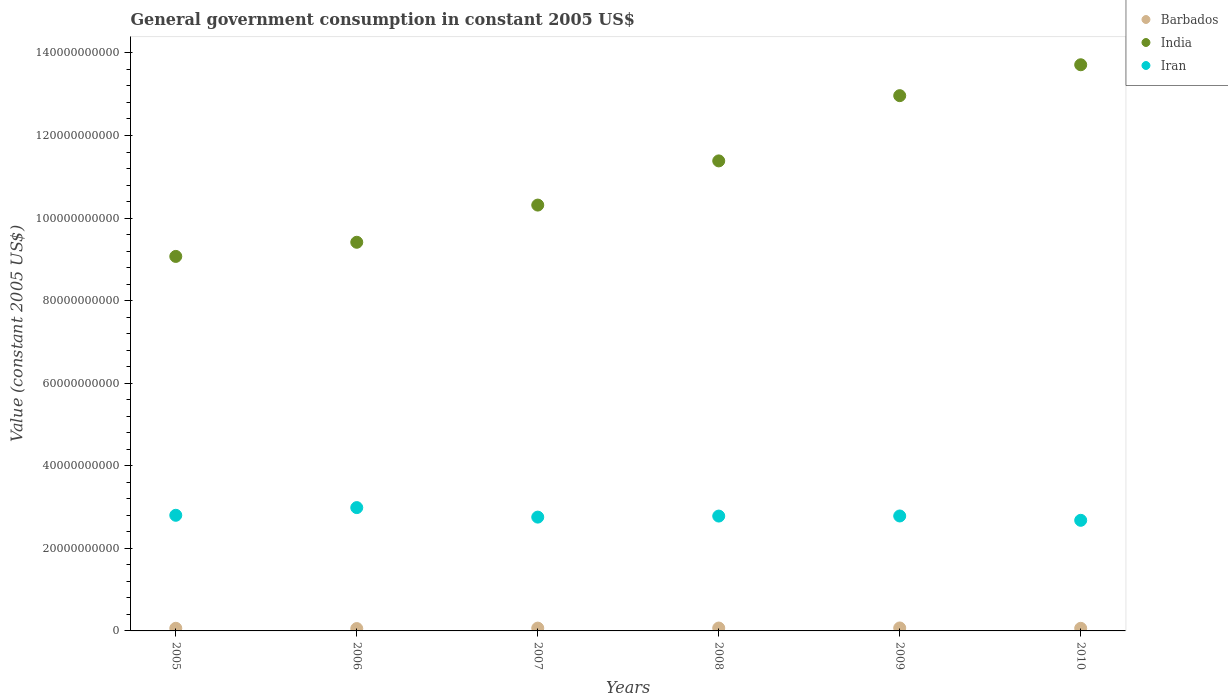How many different coloured dotlines are there?
Ensure brevity in your answer.  3. Is the number of dotlines equal to the number of legend labels?
Provide a succinct answer. Yes. What is the government conusmption in Iran in 2010?
Offer a very short reply. 2.68e+1. Across all years, what is the maximum government conusmption in Barbados?
Ensure brevity in your answer.  7.16e+08. Across all years, what is the minimum government conusmption in Iran?
Your response must be concise. 2.68e+1. In which year was the government conusmption in Iran maximum?
Your answer should be very brief. 2006. What is the total government conusmption in Barbados in the graph?
Your answer should be very brief. 3.93e+09. What is the difference between the government conusmption in India in 2007 and that in 2009?
Your answer should be very brief. -2.65e+1. What is the difference between the government conusmption in Iran in 2009 and the government conusmption in Barbados in 2007?
Provide a succinct answer. 2.72e+1. What is the average government conusmption in Barbados per year?
Your response must be concise. 6.55e+08. In the year 2010, what is the difference between the government conusmption in Iran and government conusmption in India?
Offer a very short reply. -1.10e+11. In how many years, is the government conusmption in India greater than 8000000000 US$?
Your answer should be compact. 6. What is the ratio of the government conusmption in Barbados in 2005 to that in 2009?
Your response must be concise. 0.89. What is the difference between the highest and the second highest government conusmption in Barbados?
Ensure brevity in your answer.  1.70e+07. What is the difference between the highest and the lowest government conusmption in Barbados?
Keep it short and to the point. 1.46e+08. Is the government conusmption in Barbados strictly less than the government conusmption in India over the years?
Provide a short and direct response. Yes. How many dotlines are there?
Your answer should be compact. 3. How many years are there in the graph?
Your response must be concise. 6. What is the difference between two consecutive major ticks on the Y-axis?
Your response must be concise. 2.00e+1. Are the values on the major ticks of Y-axis written in scientific E-notation?
Your response must be concise. No. Does the graph contain any zero values?
Your answer should be very brief. No. Does the graph contain grids?
Your answer should be very brief. No. What is the title of the graph?
Make the answer very short. General government consumption in constant 2005 US$. Does "Argentina" appear as one of the legend labels in the graph?
Keep it short and to the point. No. What is the label or title of the X-axis?
Make the answer very short. Years. What is the label or title of the Y-axis?
Offer a terse response. Value (constant 2005 US$). What is the Value (constant 2005 US$) in Barbados in 2005?
Your answer should be compact. 6.38e+08. What is the Value (constant 2005 US$) of India in 2005?
Make the answer very short. 9.07e+1. What is the Value (constant 2005 US$) of Iran in 2005?
Offer a very short reply. 2.80e+1. What is the Value (constant 2005 US$) in Barbados in 2006?
Your answer should be compact. 5.70e+08. What is the Value (constant 2005 US$) of India in 2006?
Provide a short and direct response. 9.41e+1. What is the Value (constant 2005 US$) of Iran in 2006?
Keep it short and to the point. 2.99e+1. What is the Value (constant 2005 US$) of Barbados in 2007?
Offer a very short reply. 6.79e+08. What is the Value (constant 2005 US$) of India in 2007?
Your response must be concise. 1.03e+11. What is the Value (constant 2005 US$) of Iran in 2007?
Provide a succinct answer. 2.76e+1. What is the Value (constant 2005 US$) in Barbados in 2008?
Offer a terse response. 6.99e+08. What is the Value (constant 2005 US$) in India in 2008?
Provide a short and direct response. 1.14e+11. What is the Value (constant 2005 US$) in Iran in 2008?
Offer a terse response. 2.78e+1. What is the Value (constant 2005 US$) in Barbados in 2009?
Make the answer very short. 7.16e+08. What is the Value (constant 2005 US$) in India in 2009?
Provide a succinct answer. 1.30e+11. What is the Value (constant 2005 US$) of Iran in 2009?
Offer a very short reply. 2.78e+1. What is the Value (constant 2005 US$) in Barbados in 2010?
Offer a very short reply. 6.31e+08. What is the Value (constant 2005 US$) of India in 2010?
Your answer should be compact. 1.37e+11. What is the Value (constant 2005 US$) of Iran in 2010?
Give a very brief answer. 2.68e+1. Across all years, what is the maximum Value (constant 2005 US$) in Barbados?
Give a very brief answer. 7.16e+08. Across all years, what is the maximum Value (constant 2005 US$) in India?
Give a very brief answer. 1.37e+11. Across all years, what is the maximum Value (constant 2005 US$) of Iran?
Provide a short and direct response. 2.99e+1. Across all years, what is the minimum Value (constant 2005 US$) of Barbados?
Offer a terse response. 5.70e+08. Across all years, what is the minimum Value (constant 2005 US$) in India?
Keep it short and to the point. 9.07e+1. Across all years, what is the minimum Value (constant 2005 US$) in Iran?
Offer a terse response. 2.68e+1. What is the total Value (constant 2005 US$) of Barbados in the graph?
Offer a terse response. 3.93e+09. What is the total Value (constant 2005 US$) in India in the graph?
Offer a terse response. 6.69e+11. What is the total Value (constant 2005 US$) of Iran in the graph?
Provide a short and direct response. 1.68e+11. What is the difference between the Value (constant 2005 US$) in Barbados in 2005 and that in 2006?
Your answer should be compact. 6.82e+07. What is the difference between the Value (constant 2005 US$) in India in 2005 and that in 2006?
Ensure brevity in your answer.  -3.42e+09. What is the difference between the Value (constant 2005 US$) in Iran in 2005 and that in 2006?
Ensure brevity in your answer.  -1.86e+09. What is the difference between the Value (constant 2005 US$) in Barbados in 2005 and that in 2007?
Provide a succinct answer. -4.14e+07. What is the difference between the Value (constant 2005 US$) of India in 2005 and that in 2007?
Keep it short and to the point. -1.24e+1. What is the difference between the Value (constant 2005 US$) of Iran in 2005 and that in 2007?
Offer a terse response. 4.43e+08. What is the difference between the Value (constant 2005 US$) of Barbados in 2005 and that in 2008?
Offer a very short reply. -6.09e+07. What is the difference between the Value (constant 2005 US$) in India in 2005 and that in 2008?
Give a very brief answer. -2.31e+1. What is the difference between the Value (constant 2005 US$) of Iran in 2005 and that in 2008?
Ensure brevity in your answer.  1.92e+08. What is the difference between the Value (constant 2005 US$) of Barbados in 2005 and that in 2009?
Make the answer very short. -7.79e+07. What is the difference between the Value (constant 2005 US$) of India in 2005 and that in 2009?
Ensure brevity in your answer.  -3.89e+1. What is the difference between the Value (constant 2005 US$) in Iran in 2005 and that in 2009?
Your response must be concise. 1.68e+08. What is the difference between the Value (constant 2005 US$) of Barbados in 2005 and that in 2010?
Offer a terse response. 7.31e+06. What is the difference between the Value (constant 2005 US$) of India in 2005 and that in 2010?
Your response must be concise. -4.64e+1. What is the difference between the Value (constant 2005 US$) in Iran in 2005 and that in 2010?
Provide a succinct answer. 1.22e+09. What is the difference between the Value (constant 2005 US$) of Barbados in 2006 and that in 2007?
Offer a terse response. -1.10e+08. What is the difference between the Value (constant 2005 US$) of India in 2006 and that in 2007?
Ensure brevity in your answer.  -9.01e+09. What is the difference between the Value (constant 2005 US$) of Iran in 2006 and that in 2007?
Give a very brief answer. 2.30e+09. What is the difference between the Value (constant 2005 US$) of Barbados in 2006 and that in 2008?
Provide a succinct answer. -1.29e+08. What is the difference between the Value (constant 2005 US$) in India in 2006 and that in 2008?
Your answer should be compact. -1.97e+1. What is the difference between the Value (constant 2005 US$) in Iran in 2006 and that in 2008?
Your answer should be compact. 2.05e+09. What is the difference between the Value (constant 2005 US$) of Barbados in 2006 and that in 2009?
Offer a terse response. -1.46e+08. What is the difference between the Value (constant 2005 US$) of India in 2006 and that in 2009?
Ensure brevity in your answer.  -3.55e+1. What is the difference between the Value (constant 2005 US$) of Iran in 2006 and that in 2009?
Provide a succinct answer. 2.03e+09. What is the difference between the Value (constant 2005 US$) of Barbados in 2006 and that in 2010?
Provide a short and direct response. -6.09e+07. What is the difference between the Value (constant 2005 US$) in India in 2006 and that in 2010?
Ensure brevity in your answer.  -4.30e+1. What is the difference between the Value (constant 2005 US$) of Iran in 2006 and that in 2010?
Make the answer very short. 3.08e+09. What is the difference between the Value (constant 2005 US$) of Barbados in 2007 and that in 2008?
Provide a succinct answer. -1.95e+07. What is the difference between the Value (constant 2005 US$) in India in 2007 and that in 2008?
Ensure brevity in your answer.  -1.07e+1. What is the difference between the Value (constant 2005 US$) of Iran in 2007 and that in 2008?
Keep it short and to the point. -2.51e+08. What is the difference between the Value (constant 2005 US$) of Barbados in 2007 and that in 2009?
Your response must be concise. -3.65e+07. What is the difference between the Value (constant 2005 US$) of India in 2007 and that in 2009?
Keep it short and to the point. -2.65e+1. What is the difference between the Value (constant 2005 US$) in Iran in 2007 and that in 2009?
Your answer should be very brief. -2.75e+08. What is the difference between the Value (constant 2005 US$) of Barbados in 2007 and that in 2010?
Offer a very short reply. 4.87e+07. What is the difference between the Value (constant 2005 US$) in India in 2007 and that in 2010?
Provide a short and direct response. -3.40e+1. What is the difference between the Value (constant 2005 US$) in Iran in 2007 and that in 2010?
Provide a succinct answer. 7.75e+08. What is the difference between the Value (constant 2005 US$) in Barbados in 2008 and that in 2009?
Your answer should be compact. -1.70e+07. What is the difference between the Value (constant 2005 US$) of India in 2008 and that in 2009?
Offer a terse response. -1.58e+1. What is the difference between the Value (constant 2005 US$) in Iran in 2008 and that in 2009?
Your answer should be compact. -2.42e+07. What is the difference between the Value (constant 2005 US$) in Barbados in 2008 and that in 2010?
Ensure brevity in your answer.  6.82e+07. What is the difference between the Value (constant 2005 US$) in India in 2008 and that in 2010?
Your answer should be compact. -2.33e+1. What is the difference between the Value (constant 2005 US$) of Iran in 2008 and that in 2010?
Provide a succinct answer. 1.03e+09. What is the difference between the Value (constant 2005 US$) of Barbados in 2009 and that in 2010?
Ensure brevity in your answer.  8.52e+07. What is the difference between the Value (constant 2005 US$) of India in 2009 and that in 2010?
Provide a short and direct response. -7.48e+09. What is the difference between the Value (constant 2005 US$) of Iran in 2009 and that in 2010?
Keep it short and to the point. 1.05e+09. What is the difference between the Value (constant 2005 US$) in Barbados in 2005 and the Value (constant 2005 US$) in India in 2006?
Provide a short and direct response. -9.35e+1. What is the difference between the Value (constant 2005 US$) in Barbados in 2005 and the Value (constant 2005 US$) in Iran in 2006?
Offer a terse response. -2.92e+1. What is the difference between the Value (constant 2005 US$) in India in 2005 and the Value (constant 2005 US$) in Iran in 2006?
Give a very brief answer. 6.08e+1. What is the difference between the Value (constant 2005 US$) in Barbados in 2005 and the Value (constant 2005 US$) in India in 2007?
Your answer should be compact. -1.03e+11. What is the difference between the Value (constant 2005 US$) of Barbados in 2005 and the Value (constant 2005 US$) of Iran in 2007?
Ensure brevity in your answer.  -2.69e+1. What is the difference between the Value (constant 2005 US$) of India in 2005 and the Value (constant 2005 US$) of Iran in 2007?
Give a very brief answer. 6.31e+1. What is the difference between the Value (constant 2005 US$) in Barbados in 2005 and the Value (constant 2005 US$) in India in 2008?
Provide a succinct answer. -1.13e+11. What is the difference between the Value (constant 2005 US$) in Barbados in 2005 and the Value (constant 2005 US$) in Iran in 2008?
Keep it short and to the point. -2.72e+1. What is the difference between the Value (constant 2005 US$) in India in 2005 and the Value (constant 2005 US$) in Iran in 2008?
Your answer should be very brief. 6.29e+1. What is the difference between the Value (constant 2005 US$) in Barbados in 2005 and the Value (constant 2005 US$) in India in 2009?
Your answer should be very brief. -1.29e+11. What is the difference between the Value (constant 2005 US$) of Barbados in 2005 and the Value (constant 2005 US$) of Iran in 2009?
Offer a terse response. -2.72e+1. What is the difference between the Value (constant 2005 US$) in India in 2005 and the Value (constant 2005 US$) in Iran in 2009?
Provide a succinct answer. 6.29e+1. What is the difference between the Value (constant 2005 US$) of Barbados in 2005 and the Value (constant 2005 US$) of India in 2010?
Give a very brief answer. -1.36e+11. What is the difference between the Value (constant 2005 US$) in Barbados in 2005 and the Value (constant 2005 US$) in Iran in 2010?
Your answer should be compact. -2.62e+1. What is the difference between the Value (constant 2005 US$) of India in 2005 and the Value (constant 2005 US$) of Iran in 2010?
Provide a succinct answer. 6.39e+1. What is the difference between the Value (constant 2005 US$) of Barbados in 2006 and the Value (constant 2005 US$) of India in 2007?
Give a very brief answer. -1.03e+11. What is the difference between the Value (constant 2005 US$) in Barbados in 2006 and the Value (constant 2005 US$) in Iran in 2007?
Provide a succinct answer. -2.70e+1. What is the difference between the Value (constant 2005 US$) of India in 2006 and the Value (constant 2005 US$) of Iran in 2007?
Keep it short and to the point. 6.66e+1. What is the difference between the Value (constant 2005 US$) in Barbados in 2006 and the Value (constant 2005 US$) in India in 2008?
Keep it short and to the point. -1.13e+11. What is the difference between the Value (constant 2005 US$) in Barbados in 2006 and the Value (constant 2005 US$) in Iran in 2008?
Your answer should be compact. -2.72e+1. What is the difference between the Value (constant 2005 US$) of India in 2006 and the Value (constant 2005 US$) of Iran in 2008?
Your response must be concise. 6.63e+1. What is the difference between the Value (constant 2005 US$) in Barbados in 2006 and the Value (constant 2005 US$) in India in 2009?
Ensure brevity in your answer.  -1.29e+11. What is the difference between the Value (constant 2005 US$) in Barbados in 2006 and the Value (constant 2005 US$) in Iran in 2009?
Offer a terse response. -2.73e+1. What is the difference between the Value (constant 2005 US$) of India in 2006 and the Value (constant 2005 US$) of Iran in 2009?
Give a very brief answer. 6.63e+1. What is the difference between the Value (constant 2005 US$) in Barbados in 2006 and the Value (constant 2005 US$) in India in 2010?
Your response must be concise. -1.37e+11. What is the difference between the Value (constant 2005 US$) of Barbados in 2006 and the Value (constant 2005 US$) of Iran in 2010?
Give a very brief answer. -2.62e+1. What is the difference between the Value (constant 2005 US$) in India in 2006 and the Value (constant 2005 US$) in Iran in 2010?
Offer a very short reply. 6.73e+1. What is the difference between the Value (constant 2005 US$) in Barbados in 2007 and the Value (constant 2005 US$) in India in 2008?
Ensure brevity in your answer.  -1.13e+11. What is the difference between the Value (constant 2005 US$) in Barbados in 2007 and the Value (constant 2005 US$) in Iran in 2008?
Offer a very short reply. -2.71e+1. What is the difference between the Value (constant 2005 US$) of India in 2007 and the Value (constant 2005 US$) of Iran in 2008?
Provide a short and direct response. 7.53e+1. What is the difference between the Value (constant 2005 US$) in Barbados in 2007 and the Value (constant 2005 US$) in India in 2009?
Offer a very short reply. -1.29e+11. What is the difference between the Value (constant 2005 US$) in Barbados in 2007 and the Value (constant 2005 US$) in Iran in 2009?
Provide a succinct answer. -2.72e+1. What is the difference between the Value (constant 2005 US$) in India in 2007 and the Value (constant 2005 US$) in Iran in 2009?
Make the answer very short. 7.53e+1. What is the difference between the Value (constant 2005 US$) in Barbados in 2007 and the Value (constant 2005 US$) in India in 2010?
Provide a succinct answer. -1.36e+11. What is the difference between the Value (constant 2005 US$) in Barbados in 2007 and the Value (constant 2005 US$) in Iran in 2010?
Give a very brief answer. -2.61e+1. What is the difference between the Value (constant 2005 US$) of India in 2007 and the Value (constant 2005 US$) of Iran in 2010?
Offer a terse response. 7.64e+1. What is the difference between the Value (constant 2005 US$) of Barbados in 2008 and the Value (constant 2005 US$) of India in 2009?
Provide a succinct answer. -1.29e+11. What is the difference between the Value (constant 2005 US$) in Barbados in 2008 and the Value (constant 2005 US$) in Iran in 2009?
Make the answer very short. -2.71e+1. What is the difference between the Value (constant 2005 US$) of India in 2008 and the Value (constant 2005 US$) of Iran in 2009?
Provide a short and direct response. 8.60e+1. What is the difference between the Value (constant 2005 US$) of Barbados in 2008 and the Value (constant 2005 US$) of India in 2010?
Offer a terse response. -1.36e+11. What is the difference between the Value (constant 2005 US$) of Barbados in 2008 and the Value (constant 2005 US$) of Iran in 2010?
Offer a very short reply. -2.61e+1. What is the difference between the Value (constant 2005 US$) in India in 2008 and the Value (constant 2005 US$) in Iran in 2010?
Ensure brevity in your answer.  8.71e+1. What is the difference between the Value (constant 2005 US$) of Barbados in 2009 and the Value (constant 2005 US$) of India in 2010?
Provide a short and direct response. -1.36e+11. What is the difference between the Value (constant 2005 US$) of Barbados in 2009 and the Value (constant 2005 US$) of Iran in 2010?
Your answer should be very brief. -2.61e+1. What is the difference between the Value (constant 2005 US$) of India in 2009 and the Value (constant 2005 US$) of Iran in 2010?
Your answer should be very brief. 1.03e+11. What is the average Value (constant 2005 US$) of Barbados per year?
Keep it short and to the point. 6.55e+08. What is the average Value (constant 2005 US$) of India per year?
Your answer should be very brief. 1.11e+11. What is the average Value (constant 2005 US$) in Iran per year?
Give a very brief answer. 2.80e+1. In the year 2005, what is the difference between the Value (constant 2005 US$) of Barbados and Value (constant 2005 US$) of India?
Ensure brevity in your answer.  -9.01e+1. In the year 2005, what is the difference between the Value (constant 2005 US$) in Barbados and Value (constant 2005 US$) in Iran?
Provide a short and direct response. -2.74e+1. In the year 2005, what is the difference between the Value (constant 2005 US$) of India and Value (constant 2005 US$) of Iran?
Keep it short and to the point. 6.27e+1. In the year 2006, what is the difference between the Value (constant 2005 US$) in Barbados and Value (constant 2005 US$) in India?
Offer a terse response. -9.36e+1. In the year 2006, what is the difference between the Value (constant 2005 US$) in Barbados and Value (constant 2005 US$) in Iran?
Your answer should be very brief. -2.93e+1. In the year 2006, what is the difference between the Value (constant 2005 US$) of India and Value (constant 2005 US$) of Iran?
Offer a very short reply. 6.43e+1. In the year 2007, what is the difference between the Value (constant 2005 US$) of Barbados and Value (constant 2005 US$) of India?
Keep it short and to the point. -1.02e+11. In the year 2007, what is the difference between the Value (constant 2005 US$) in Barbados and Value (constant 2005 US$) in Iran?
Your answer should be compact. -2.69e+1. In the year 2007, what is the difference between the Value (constant 2005 US$) of India and Value (constant 2005 US$) of Iran?
Offer a very short reply. 7.56e+1. In the year 2008, what is the difference between the Value (constant 2005 US$) of Barbados and Value (constant 2005 US$) of India?
Your response must be concise. -1.13e+11. In the year 2008, what is the difference between the Value (constant 2005 US$) in Barbados and Value (constant 2005 US$) in Iran?
Your answer should be compact. -2.71e+1. In the year 2008, what is the difference between the Value (constant 2005 US$) of India and Value (constant 2005 US$) of Iran?
Your answer should be compact. 8.60e+1. In the year 2009, what is the difference between the Value (constant 2005 US$) of Barbados and Value (constant 2005 US$) of India?
Give a very brief answer. -1.29e+11. In the year 2009, what is the difference between the Value (constant 2005 US$) in Barbados and Value (constant 2005 US$) in Iran?
Offer a very short reply. -2.71e+1. In the year 2009, what is the difference between the Value (constant 2005 US$) in India and Value (constant 2005 US$) in Iran?
Provide a short and direct response. 1.02e+11. In the year 2010, what is the difference between the Value (constant 2005 US$) in Barbados and Value (constant 2005 US$) in India?
Your response must be concise. -1.37e+11. In the year 2010, what is the difference between the Value (constant 2005 US$) of Barbados and Value (constant 2005 US$) of Iran?
Your answer should be very brief. -2.62e+1. In the year 2010, what is the difference between the Value (constant 2005 US$) in India and Value (constant 2005 US$) in Iran?
Make the answer very short. 1.10e+11. What is the ratio of the Value (constant 2005 US$) of Barbados in 2005 to that in 2006?
Provide a succinct answer. 1.12. What is the ratio of the Value (constant 2005 US$) of India in 2005 to that in 2006?
Offer a terse response. 0.96. What is the ratio of the Value (constant 2005 US$) of Iran in 2005 to that in 2006?
Keep it short and to the point. 0.94. What is the ratio of the Value (constant 2005 US$) of Barbados in 2005 to that in 2007?
Provide a short and direct response. 0.94. What is the ratio of the Value (constant 2005 US$) of India in 2005 to that in 2007?
Keep it short and to the point. 0.88. What is the ratio of the Value (constant 2005 US$) of Iran in 2005 to that in 2007?
Ensure brevity in your answer.  1.02. What is the ratio of the Value (constant 2005 US$) in Barbados in 2005 to that in 2008?
Your response must be concise. 0.91. What is the ratio of the Value (constant 2005 US$) of India in 2005 to that in 2008?
Keep it short and to the point. 0.8. What is the ratio of the Value (constant 2005 US$) in Barbados in 2005 to that in 2009?
Ensure brevity in your answer.  0.89. What is the ratio of the Value (constant 2005 US$) in India in 2005 to that in 2009?
Make the answer very short. 0.7. What is the ratio of the Value (constant 2005 US$) in Iran in 2005 to that in 2009?
Your answer should be very brief. 1.01. What is the ratio of the Value (constant 2005 US$) of Barbados in 2005 to that in 2010?
Give a very brief answer. 1.01. What is the ratio of the Value (constant 2005 US$) of India in 2005 to that in 2010?
Provide a short and direct response. 0.66. What is the ratio of the Value (constant 2005 US$) of Iran in 2005 to that in 2010?
Offer a very short reply. 1.05. What is the ratio of the Value (constant 2005 US$) of Barbados in 2006 to that in 2007?
Your answer should be compact. 0.84. What is the ratio of the Value (constant 2005 US$) in India in 2006 to that in 2007?
Provide a short and direct response. 0.91. What is the ratio of the Value (constant 2005 US$) in Iran in 2006 to that in 2007?
Give a very brief answer. 1.08. What is the ratio of the Value (constant 2005 US$) in Barbados in 2006 to that in 2008?
Your answer should be compact. 0.82. What is the ratio of the Value (constant 2005 US$) of India in 2006 to that in 2008?
Give a very brief answer. 0.83. What is the ratio of the Value (constant 2005 US$) of Iran in 2006 to that in 2008?
Keep it short and to the point. 1.07. What is the ratio of the Value (constant 2005 US$) in Barbados in 2006 to that in 2009?
Provide a succinct answer. 0.8. What is the ratio of the Value (constant 2005 US$) in India in 2006 to that in 2009?
Provide a short and direct response. 0.73. What is the ratio of the Value (constant 2005 US$) in Iran in 2006 to that in 2009?
Offer a terse response. 1.07. What is the ratio of the Value (constant 2005 US$) of Barbados in 2006 to that in 2010?
Your response must be concise. 0.9. What is the ratio of the Value (constant 2005 US$) in India in 2006 to that in 2010?
Your answer should be compact. 0.69. What is the ratio of the Value (constant 2005 US$) of Iran in 2006 to that in 2010?
Provide a succinct answer. 1.11. What is the ratio of the Value (constant 2005 US$) of Barbados in 2007 to that in 2008?
Offer a terse response. 0.97. What is the ratio of the Value (constant 2005 US$) of India in 2007 to that in 2008?
Your answer should be very brief. 0.91. What is the ratio of the Value (constant 2005 US$) of Iran in 2007 to that in 2008?
Make the answer very short. 0.99. What is the ratio of the Value (constant 2005 US$) of Barbados in 2007 to that in 2009?
Your response must be concise. 0.95. What is the ratio of the Value (constant 2005 US$) in India in 2007 to that in 2009?
Ensure brevity in your answer.  0.8. What is the ratio of the Value (constant 2005 US$) in Iran in 2007 to that in 2009?
Offer a terse response. 0.99. What is the ratio of the Value (constant 2005 US$) of Barbados in 2007 to that in 2010?
Provide a short and direct response. 1.08. What is the ratio of the Value (constant 2005 US$) in India in 2007 to that in 2010?
Your response must be concise. 0.75. What is the ratio of the Value (constant 2005 US$) in Iran in 2007 to that in 2010?
Give a very brief answer. 1.03. What is the ratio of the Value (constant 2005 US$) of Barbados in 2008 to that in 2009?
Provide a succinct answer. 0.98. What is the ratio of the Value (constant 2005 US$) of India in 2008 to that in 2009?
Offer a very short reply. 0.88. What is the ratio of the Value (constant 2005 US$) of Iran in 2008 to that in 2009?
Make the answer very short. 1. What is the ratio of the Value (constant 2005 US$) in Barbados in 2008 to that in 2010?
Your answer should be very brief. 1.11. What is the ratio of the Value (constant 2005 US$) of India in 2008 to that in 2010?
Keep it short and to the point. 0.83. What is the ratio of the Value (constant 2005 US$) in Iran in 2008 to that in 2010?
Your response must be concise. 1.04. What is the ratio of the Value (constant 2005 US$) of Barbados in 2009 to that in 2010?
Your response must be concise. 1.14. What is the ratio of the Value (constant 2005 US$) of India in 2009 to that in 2010?
Your answer should be very brief. 0.95. What is the ratio of the Value (constant 2005 US$) of Iran in 2009 to that in 2010?
Your answer should be compact. 1.04. What is the difference between the highest and the second highest Value (constant 2005 US$) in Barbados?
Give a very brief answer. 1.70e+07. What is the difference between the highest and the second highest Value (constant 2005 US$) of India?
Your answer should be compact. 7.48e+09. What is the difference between the highest and the second highest Value (constant 2005 US$) of Iran?
Keep it short and to the point. 1.86e+09. What is the difference between the highest and the lowest Value (constant 2005 US$) of Barbados?
Your response must be concise. 1.46e+08. What is the difference between the highest and the lowest Value (constant 2005 US$) of India?
Offer a very short reply. 4.64e+1. What is the difference between the highest and the lowest Value (constant 2005 US$) in Iran?
Provide a short and direct response. 3.08e+09. 